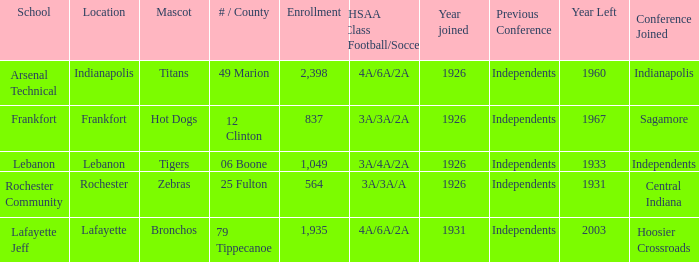What is the lowest enrollment that has Lafayette as the location? 1935.0. 